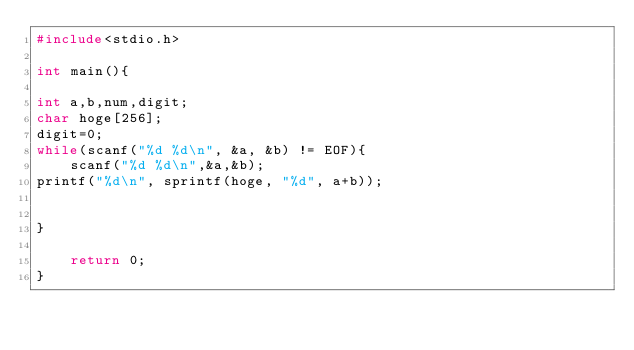<code> <loc_0><loc_0><loc_500><loc_500><_C_>#include<stdio.h>
  
int main(){
  
int a,b,num,digit;
char hoge[256];
digit=0;  
while(scanf("%d %d\n", &a, &b) != EOF){
    scanf("%d %d\n",&a,&b);
printf("%d\n", sprintf(hoge, "%d", a+b));


}
  
    return 0;
}</code> 